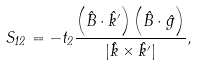Convert formula to latex. <formula><loc_0><loc_0><loc_500><loc_500>S _ { 1 2 } = - t _ { 2 } \frac { \left ( \hat { B } \cdot \hat { k } ^ { \prime } \right ) \left ( \hat { B } \cdot \hat { g } \right ) } { | \hat { k } \times \hat { k } ^ { \prime } | } ,</formula> 